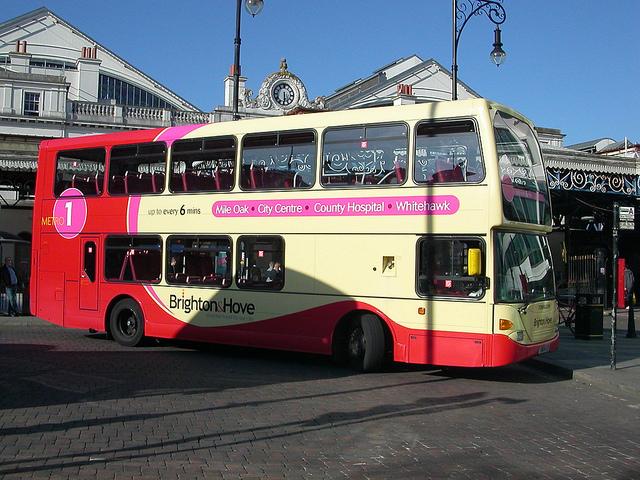Is there a cover on the top of the bus?
Be succinct. Yes. What does the pink marking on the bus mean?
Be succinct. Hospital. Does the paint job look hand painted?
Concise answer only. No. Is it cloudy?
Be succinct. No. Is this a single or double bus?
Be succinct. Double. 